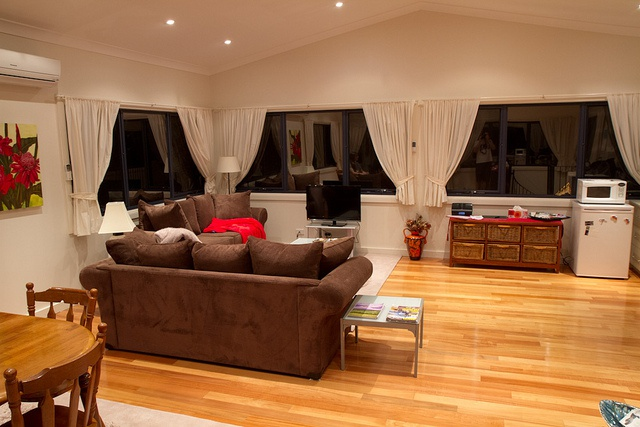Describe the objects in this image and their specific colors. I can see couch in gray, maroon, black, and brown tones, chair in gray, maroon, black, brown, and tan tones, dining table in gray, red, orange, and maroon tones, refrigerator in gray and tan tones, and chair in gray, maroon, tan, and brown tones in this image. 